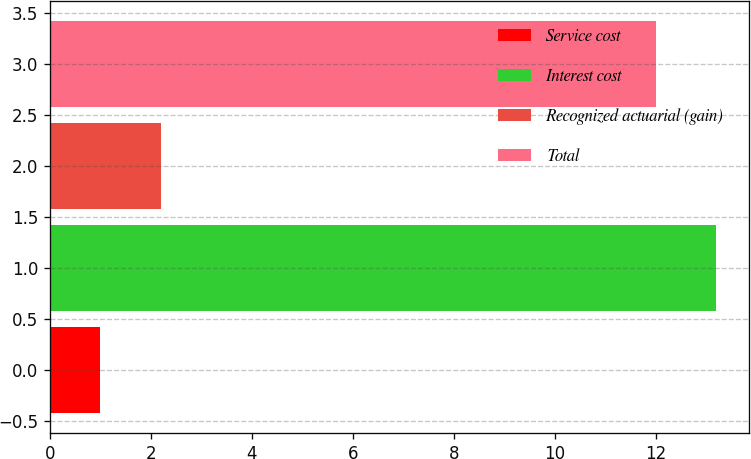Convert chart to OTSL. <chart><loc_0><loc_0><loc_500><loc_500><bar_chart><fcel>Service cost<fcel>Interest cost<fcel>Recognized actuarial (gain)<fcel>Total<nl><fcel>1<fcel>13.2<fcel>2.2<fcel>12<nl></chart> 